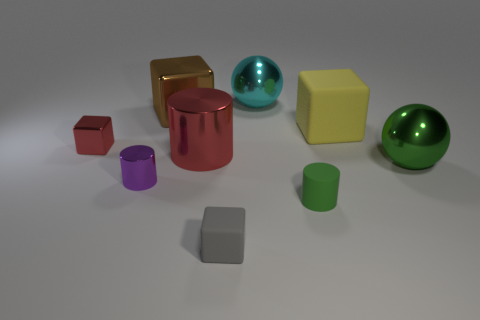There is a object that is the same color as the large metal cylinder; what is it made of?
Give a very brief answer. Metal. What is the shape of the metallic object that is to the right of the ball that is on the left side of the metallic ball in front of the red cube?
Give a very brief answer. Sphere. What number of blue things are the same material as the small purple object?
Your answer should be compact. 0. There is a big ball that is left of the tiny matte cylinder; how many tiny blocks are to the right of it?
Provide a short and direct response. 0. What number of brown matte cylinders are there?
Ensure brevity in your answer.  0. Are the gray thing and the red object that is right of the tiny red object made of the same material?
Offer a terse response. No. There is a sphere in front of the large cyan sphere; does it have the same color as the small rubber cylinder?
Your response must be concise. Yes. There is a big thing that is to the left of the green ball and in front of the yellow matte thing; what material is it?
Ensure brevity in your answer.  Metal. The brown block has what size?
Make the answer very short. Large. Do the large cylinder and the metallic thing left of the small metallic cylinder have the same color?
Offer a terse response. Yes. 